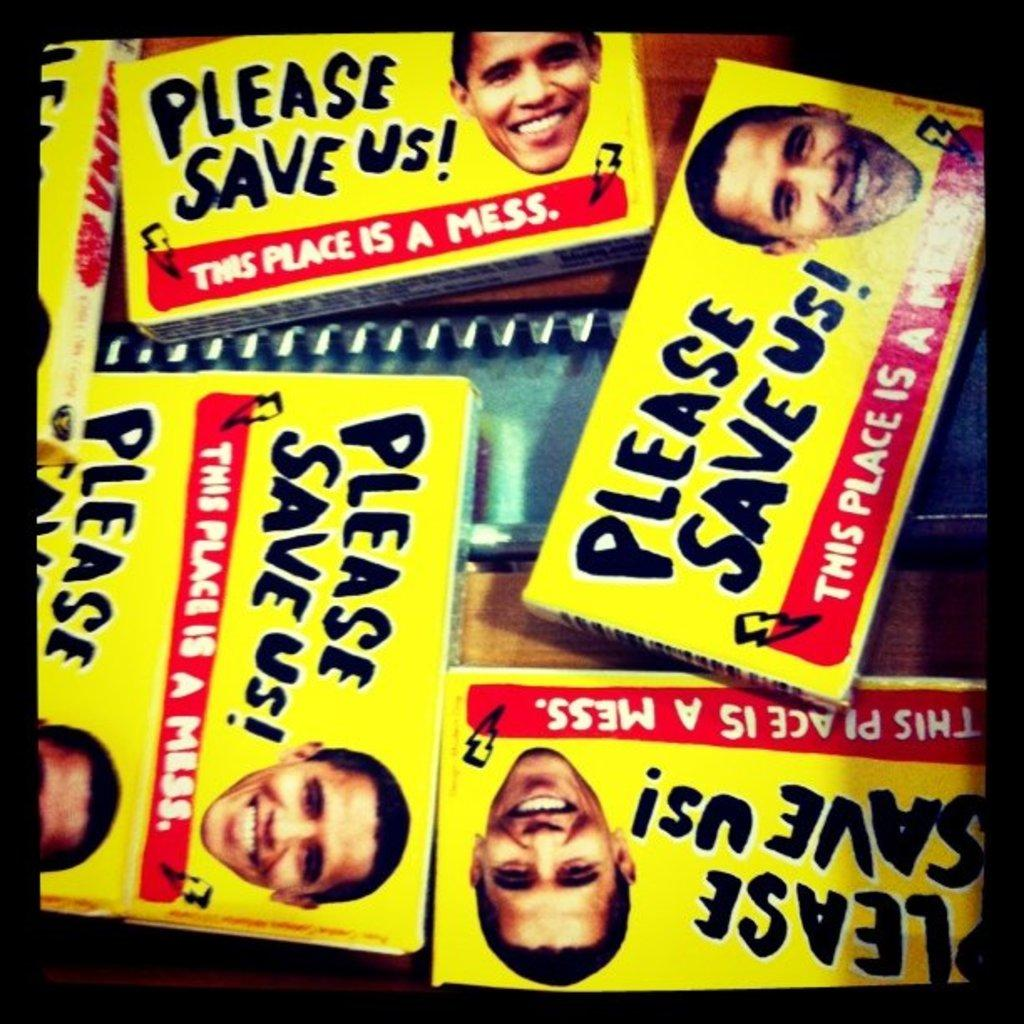What is placed on the brown surface in the image? There are packets on a brown surface. What colors are the packets? The packets are in yellow and red colors. What feature do the packets have? The packets have faces on them. What can be seen written on the packets? There is something written on the packets. What type of object made of steel can be seen in the image? There is a steel object in the image. What type of butter is being regretted in the image? There is no butter or any indication of regret present in the image. 